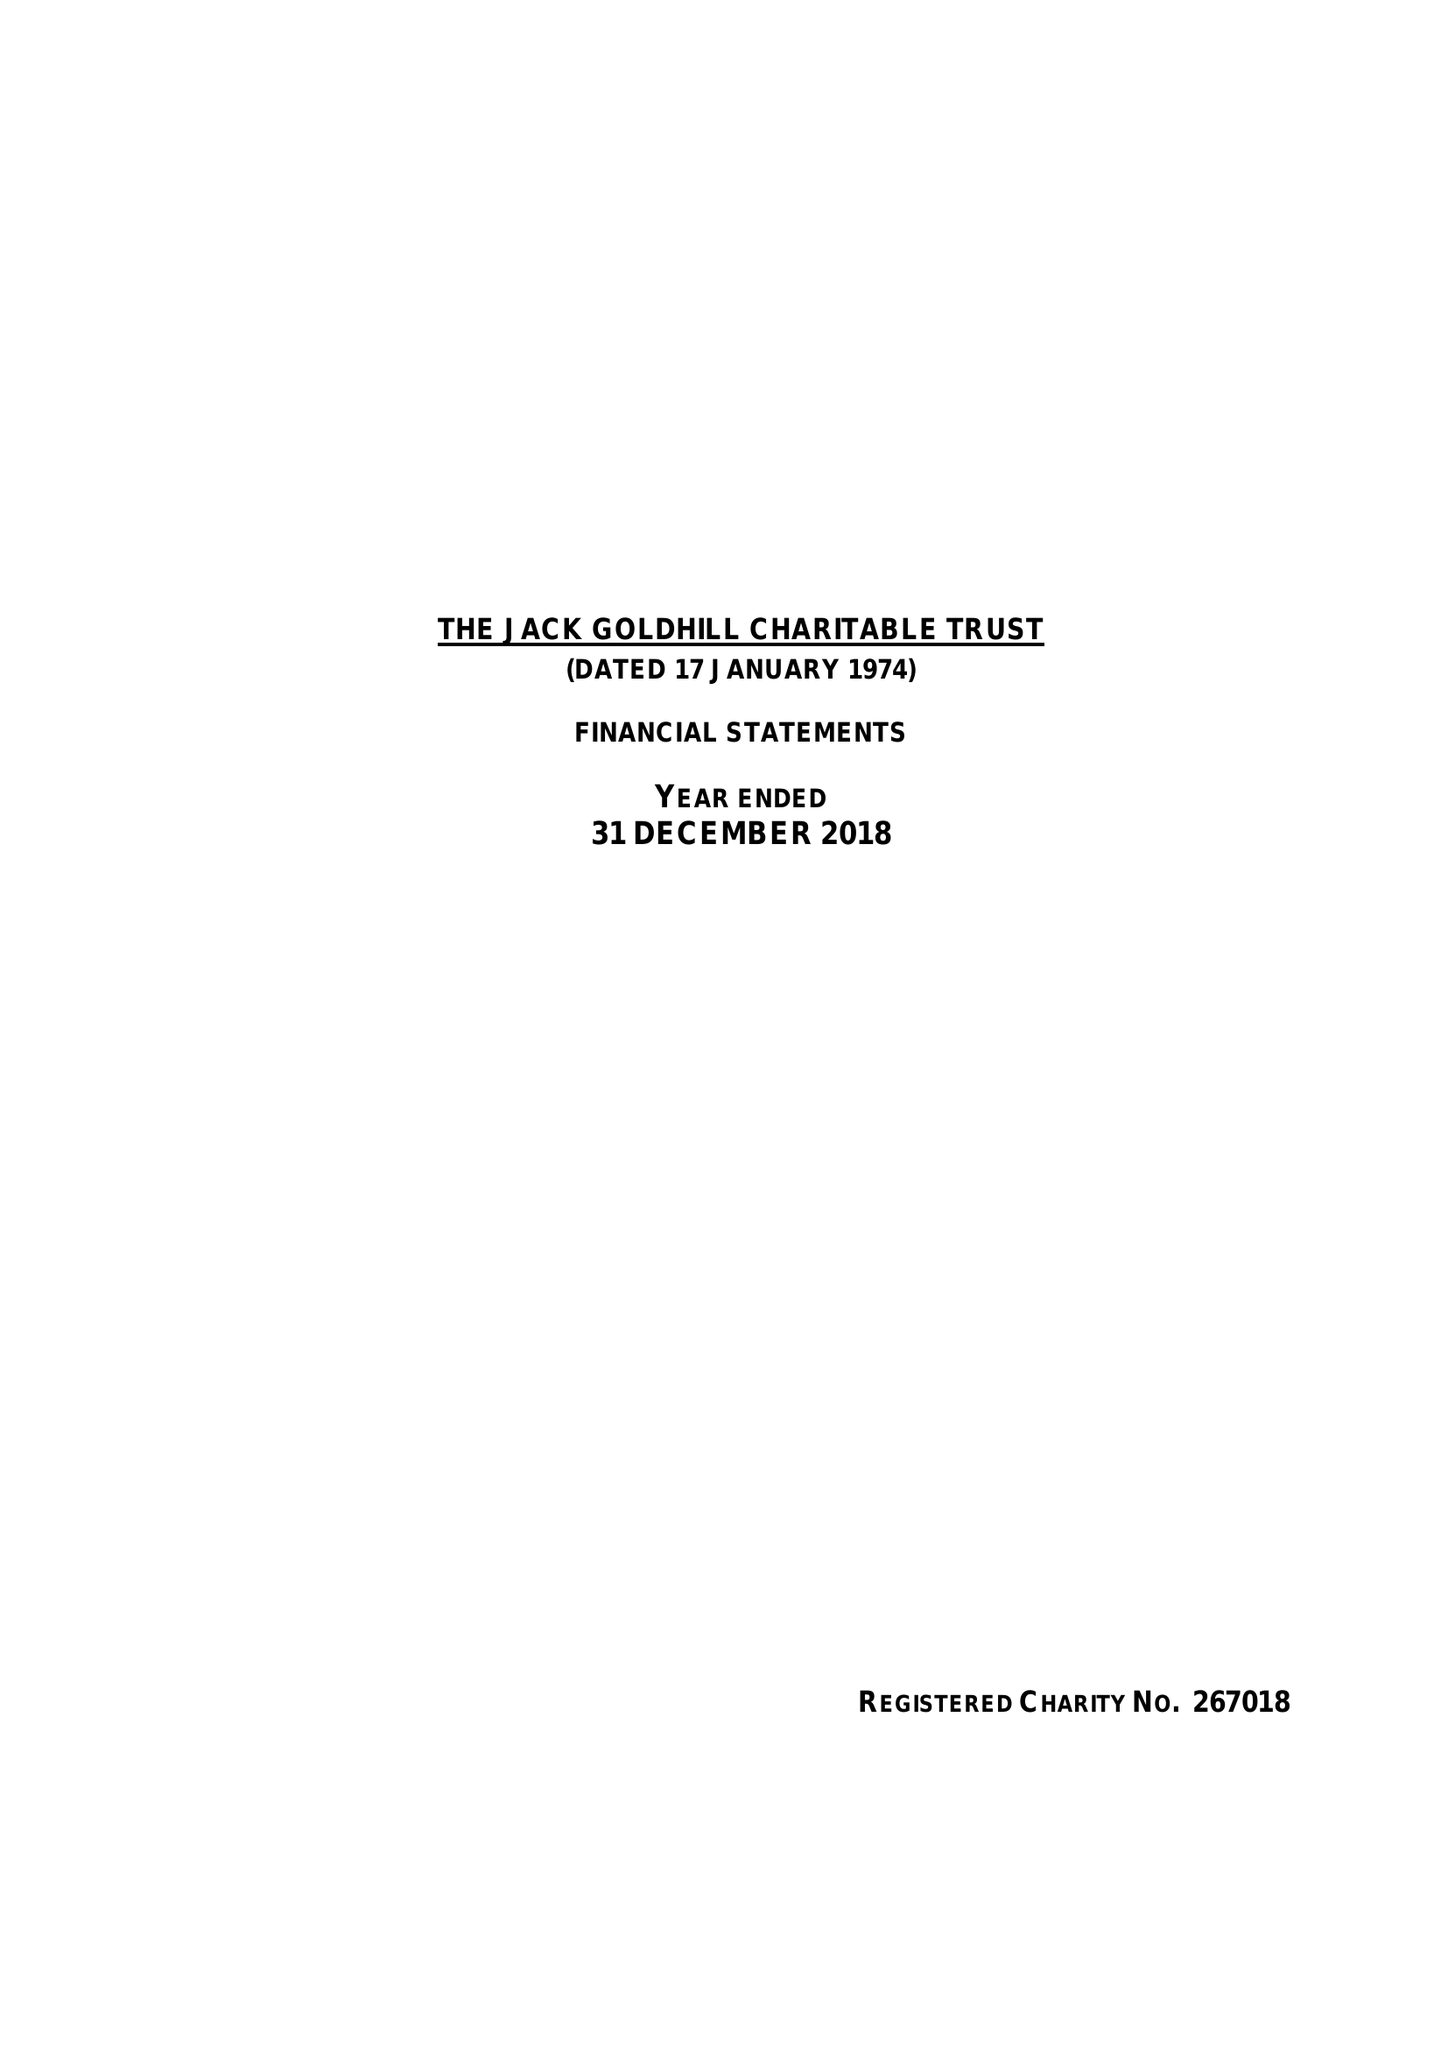What is the value for the address__postcode?
Answer the question using a single word or phrase. W1W 6AN 